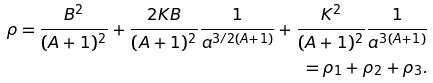Convert formula to latex. <formula><loc_0><loc_0><loc_500><loc_500>\rho = \frac { B ^ { 2 } } { ( A + 1 ) ^ { 2 } } + \frac { 2 K B } { ( A + 1 ) ^ { 2 } } \frac { 1 } { a ^ { 3 / 2 ( A + 1 ) } } + \frac { K ^ { 2 } } { ( A + 1 ) ^ { 2 } } \frac { 1 } { a ^ { 3 ( A + 1 ) } } \\ = \rho _ { 1 } + \rho _ { 2 } + \rho _ { 3 } .</formula> 